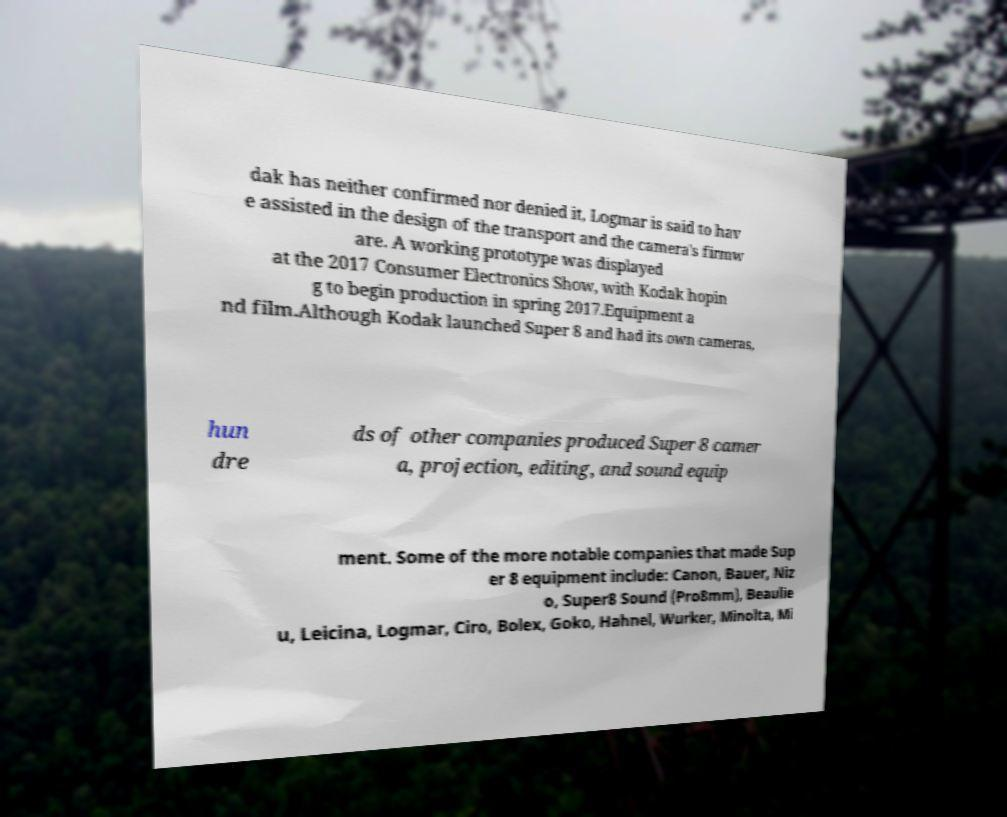Can you read and provide the text displayed in the image?This photo seems to have some interesting text. Can you extract and type it out for me? dak has neither confirmed nor denied it, Logmar is said to hav e assisted in the design of the transport and the camera's firmw are. A working prototype was displayed at the 2017 Consumer Electronics Show, with Kodak hopin g to begin production in spring 2017.Equipment a nd film.Although Kodak launched Super 8 and had its own cameras, hun dre ds of other companies produced Super 8 camer a, projection, editing, and sound equip ment. Some of the more notable companies that made Sup er 8 equipment include: Canon, Bauer, Niz o, Super8 Sound (Pro8mm), Beaulie u, Leicina, Logmar, Ciro, Bolex, Goko, Hahnel, Wurker, Minolta, Mi 